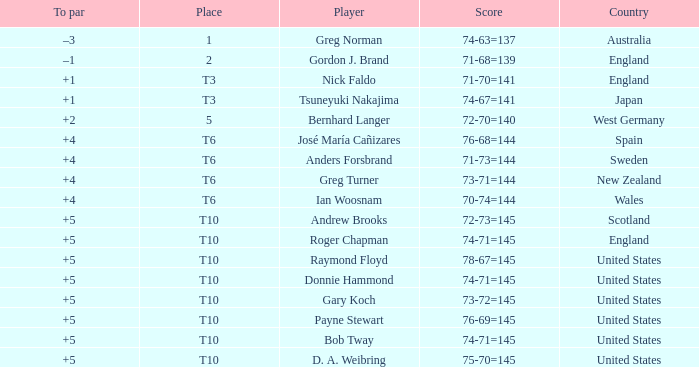Would you mind parsing the complete table? {'header': ['To par', 'Place', 'Player', 'Score', 'Country'], 'rows': [['–3', '1', 'Greg Norman', '74-63=137', 'Australia'], ['–1', '2', 'Gordon J. Brand', '71-68=139', 'England'], ['+1', 'T3', 'Nick Faldo', '71-70=141', 'England'], ['+1', 'T3', 'Tsuneyuki Nakajima', '74-67=141', 'Japan'], ['+2', '5', 'Bernhard Langer', '72-70=140', 'West Germany'], ['+4', 'T6', 'José María Cañizares', '76-68=144', 'Spain'], ['+4', 'T6', 'Anders Forsbrand', '71-73=144', 'Sweden'], ['+4', 'T6', 'Greg Turner', '73-71=144', 'New Zealand'], ['+4', 'T6', 'Ian Woosnam', '70-74=144', 'Wales'], ['+5', 'T10', 'Andrew Brooks', '72-73=145', 'Scotland'], ['+5', 'T10', 'Roger Chapman', '74-71=145', 'England'], ['+5', 'T10', 'Raymond Floyd', '78-67=145', 'United States'], ['+5', 'T10', 'Donnie Hammond', '74-71=145', 'United States'], ['+5', 'T10', 'Gary Koch', '73-72=145', 'United States'], ['+5', 'T10', 'Payne Stewart', '76-69=145', 'United States'], ['+5', 'T10', 'Bob Tway', '74-71=145', 'United States'], ['+5', 'T10', 'D. A. Weibring', '75-70=145', 'United States']]} What country did Raymond Floyd play for? United States. 